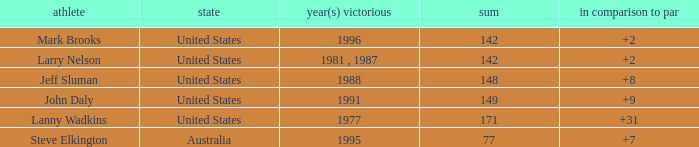Name the Total of australia and a To par smaller than 7? None. 